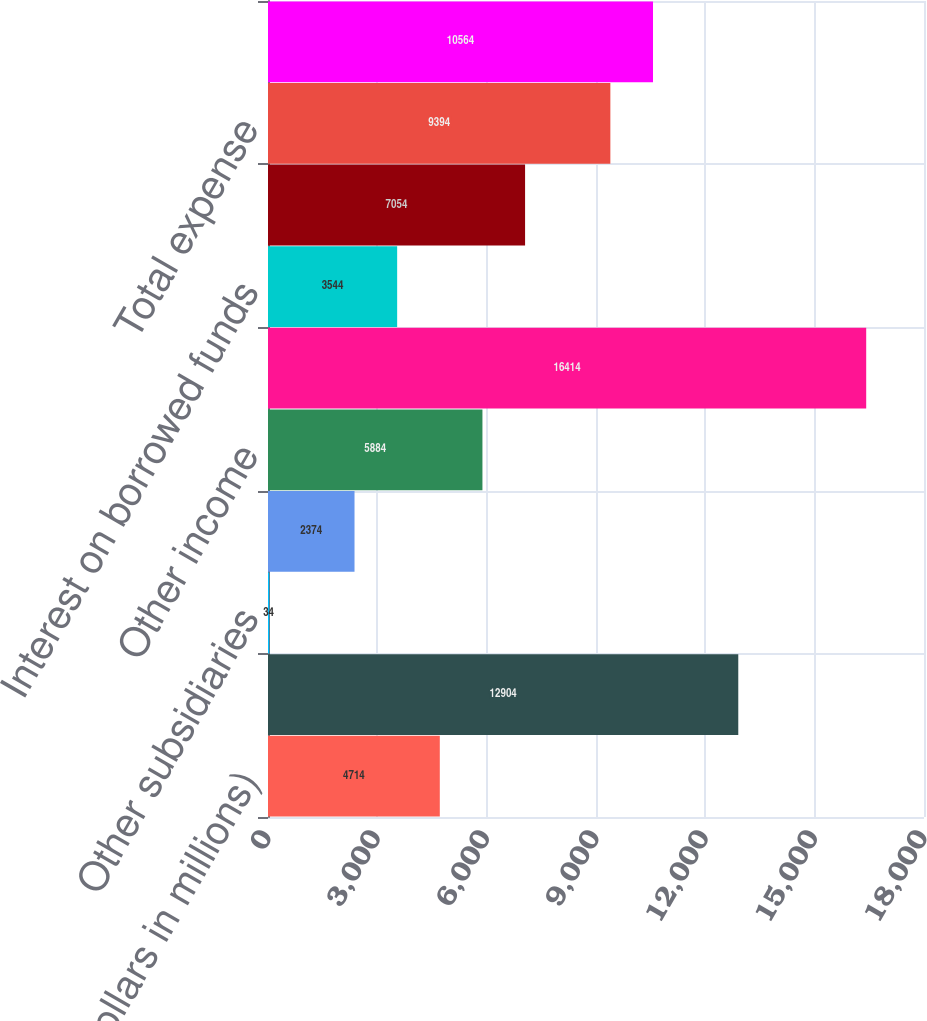Convert chart to OTSL. <chart><loc_0><loc_0><loc_500><loc_500><bar_chart><fcel>(Dollars in millions)<fcel>Bank subsidiaries<fcel>Other subsidiaries<fcel>Interest from subsidiaries<fcel>Other income<fcel>Total income<fcel>Interest on borrowed funds<fcel>Noninterest expense<fcel>Total expense<fcel>Income before income taxes and<nl><fcel>4714<fcel>12904<fcel>34<fcel>2374<fcel>5884<fcel>16414<fcel>3544<fcel>7054<fcel>9394<fcel>10564<nl></chart> 